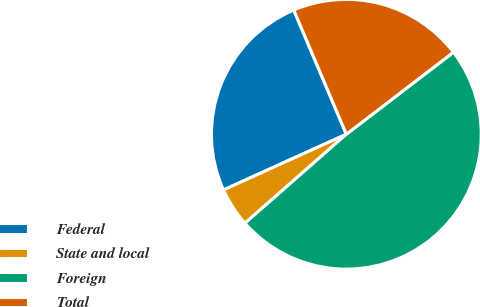Convert chart to OTSL. <chart><loc_0><loc_0><loc_500><loc_500><pie_chart><fcel>Federal<fcel>State and local<fcel>Foreign<fcel>Total<nl><fcel>25.4%<fcel>4.69%<fcel>48.94%<fcel>20.97%<nl></chart> 